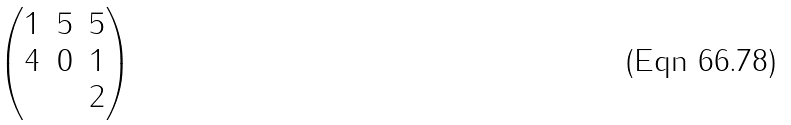Convert formula to latex. <formula><loc_0><loc_0><loc_500><loc_500>\begin{pmatrix} 1 & 5 & 5 \\ 4 & 0 & 1 \\ & & 2 \end{pmatrix}</formula> 